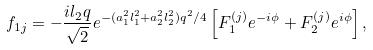<formula> <loc_0><loc_0><loc_500><loc_500>f _ { 1 j } = - \frac { i l _ { 2 } q } { \sqrt { 2 } } e ^ { - ( a _ { 1 } ^ { 2 } l _ { 1 } ^ { 2 } + a _ { 2 } ^ { 2 } l _ { 2 } ^ { 2 } ) q ^ { 2 } / 4 } \left [ F ^ { ( j ) } _ { 1 } e ^ { - i \phi } + F ^ { ( j ) } _ { 2 } e ^ { i \phi } \right ] ,</formula> 